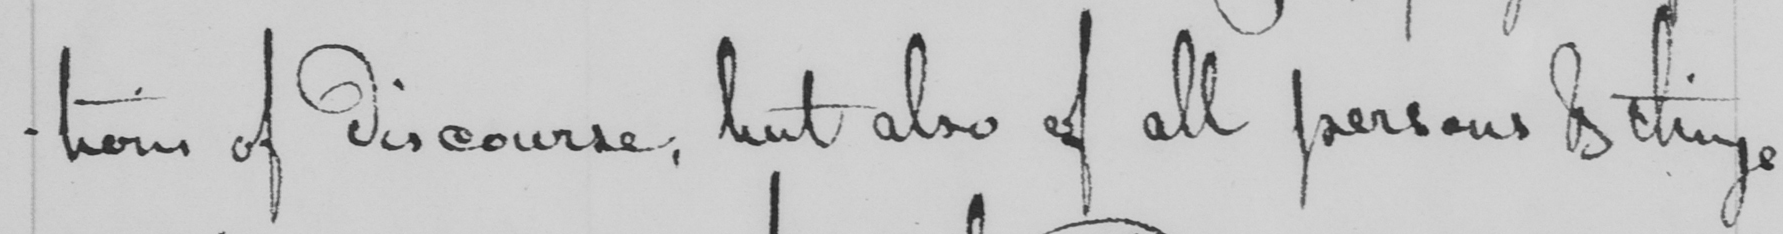What does this handwritten line say? -tions of discourse , but also of all persons & things 